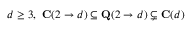<formula> <loc_0><loc_0><loc_500><loc_500>d \geq 3 , C ( 2 \to d ) \subseteq Q ( 2 \to d ) \subsetneq C ( d )</formula> 